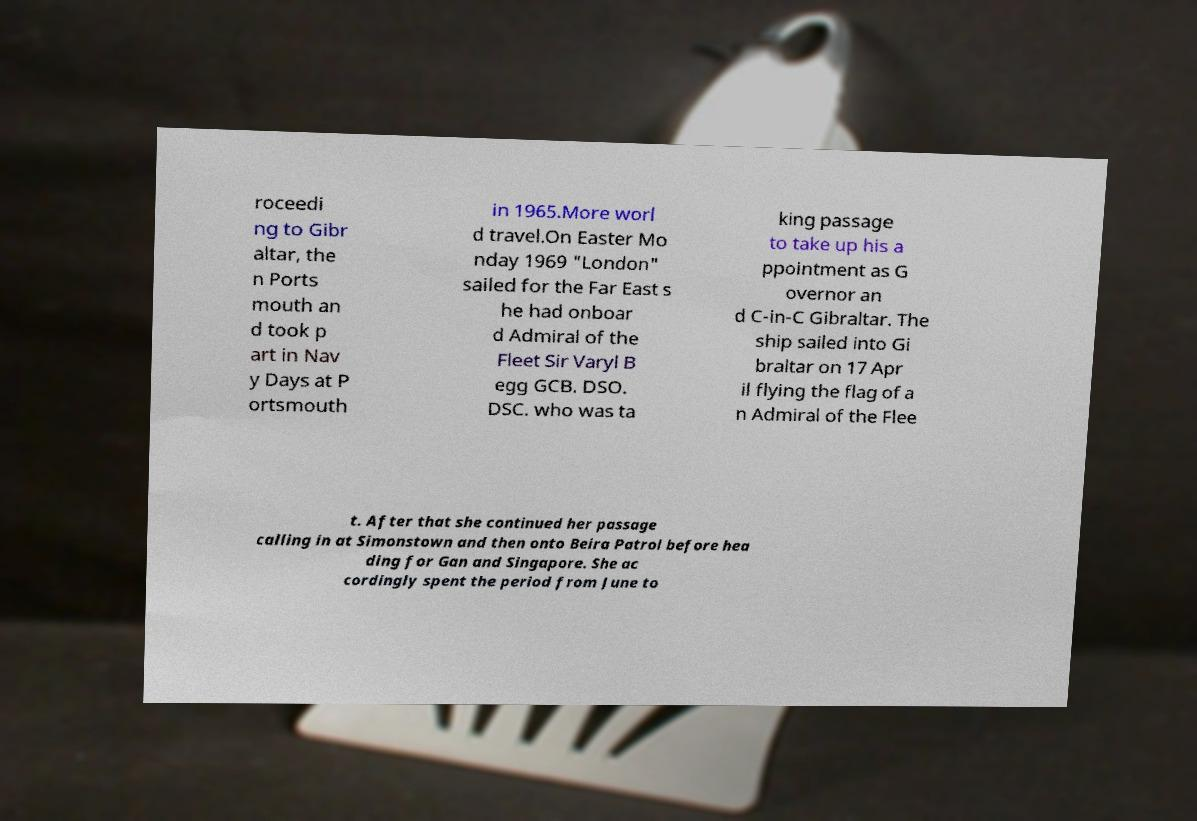Please identify and transcribe the text found in this image. roceedi ng to Gibr altar, the n Ports mouth an d took p art in Nav y Days at P ortsmouth in 1965.More worl d travel.On Easter Mo nday 1969 "London" sailed for the Far East s he had onboar d Admiral of the Fleet Sir Varyl B egg GCB. DSO. DSC. who was ta king passage to take up his a ppointment as G overnor an d C-in-C Gibraltar. The ship sailed into Gi braltar on 17 Apr il flying the flag of a n Admiral of the Flee t. After that she continued her passage calling in at Simonstown and then onto Beira Patrol before hea ding for Gan and Singapore. She ac cordingly spent the period from June to 